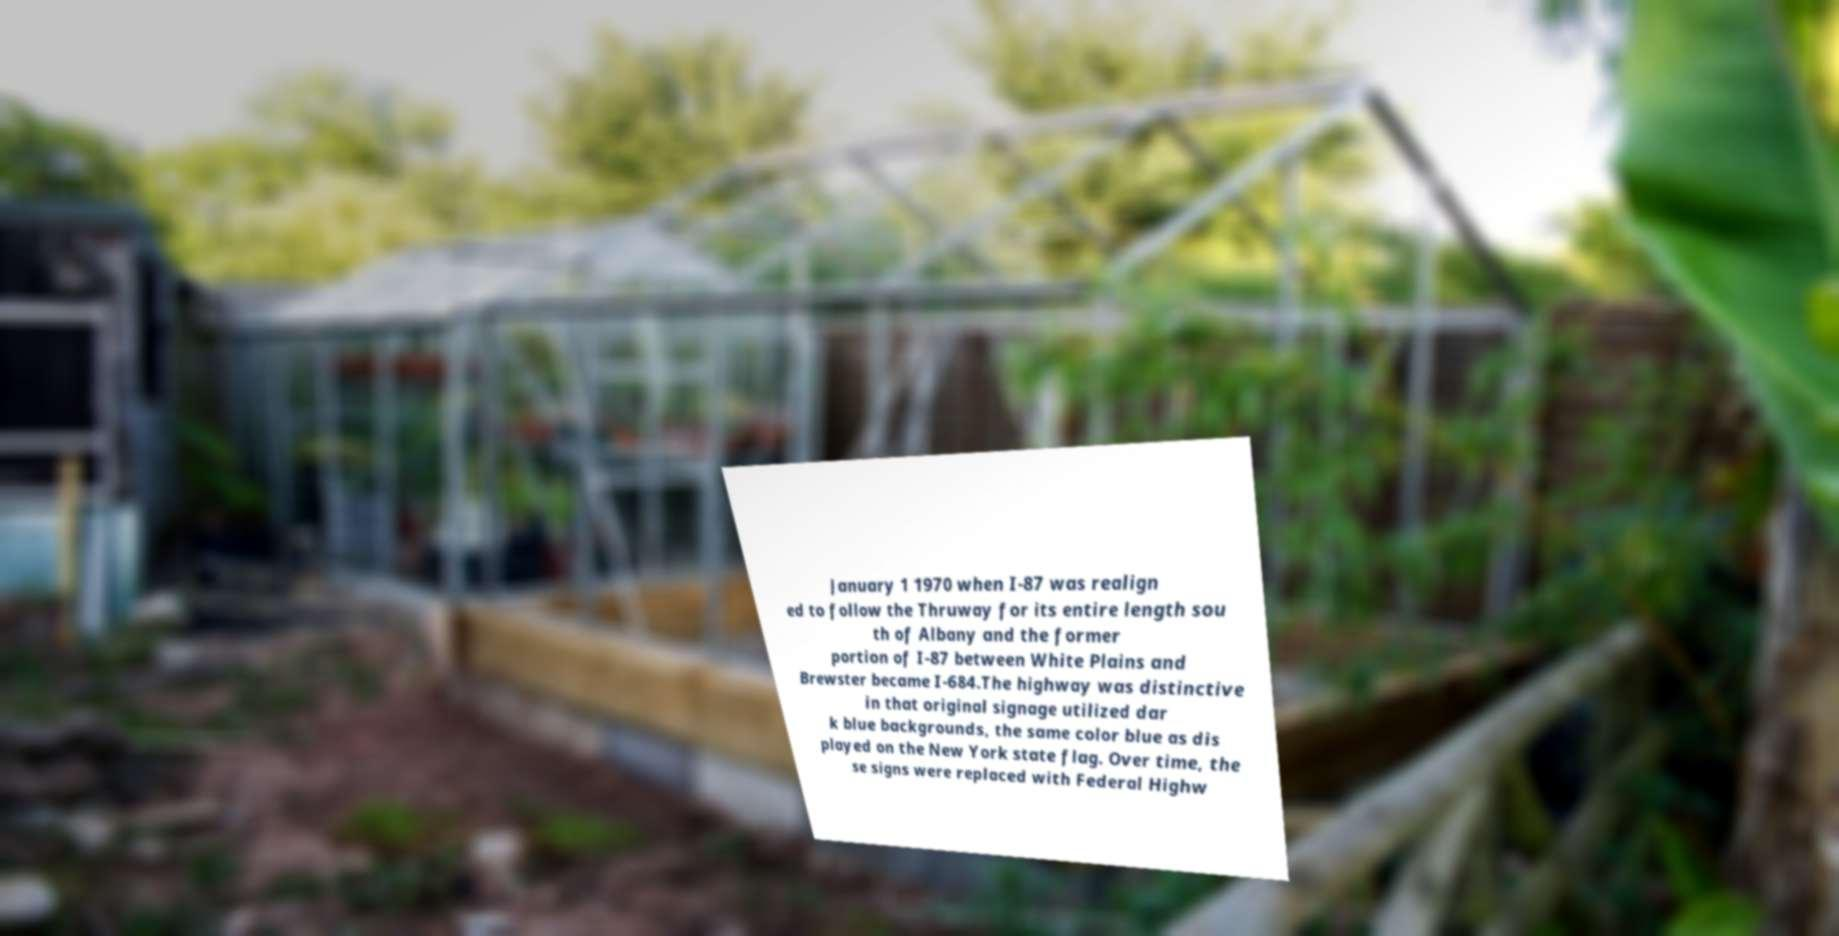There's text embedded in this image that I need extracted. Can you transcribe it verbatim? January 1 1970 when I-87 was realign ed to follow the Thruway for its entire length sou th of Albany and the former portion of I-87 between White Plains and Brewster became I-684.The highway was distinctive in that original signage utilized dar k blue backgrounds, the same color blue as dis played on the New York state flag. Over time, the se signs were replaced with Federal Highw 